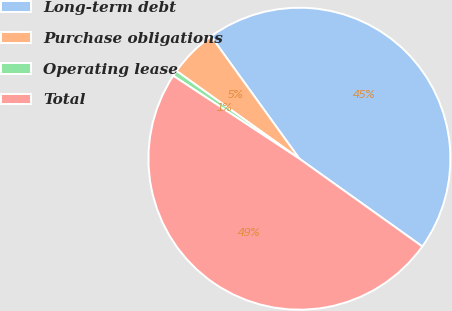Convert chart. <chart><loc_0><loc_0><loc_500><loc_500><pie_chart><fcel>Long-term debt<fcel>Purchase obligations<fcel>Operating lease<fcel>Total<nl><fcel>44.82%<fcel>5.18%<fcel>0.61%<fcel>49.39%<nl></chart> 